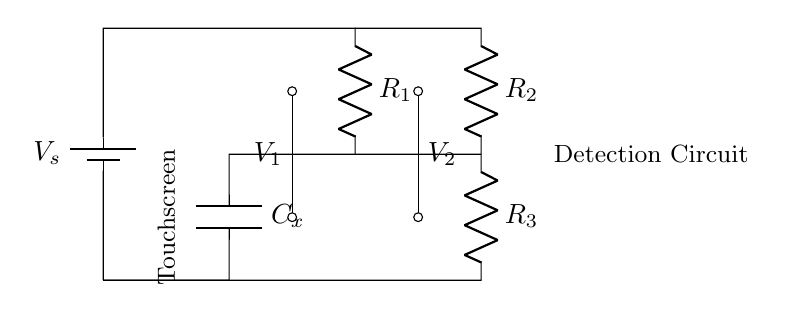What are the components used in the circuit? The circuit consists of a battery, resistors (R1, R2, R3), and a capacitor (Cx). Each component is crucial for the functioning of the capacitive bridge.
Answer: battery, resistors, capacitor What is the function of the capacitor in this circuit? The capacitor, labeled Cx, is used to detect changes in capacitance which corresponds to touch input on the touchscreen. It acts as the sensing element in the bridge circuit.
Answer: detect touch What is the voltage source labeled in the circuit? The voltage source is labeled as V_s, which is the supply voltage for the circuit. This component provides the necessary potential difference needed for the operation of the resistors and capacitor.
Answer: V_s Which resistors are in parallel with the capacitor? Resistors R1 and R3 are connected in parallel with the capacitor. This configuration forms part of the capacitive bridge, allowing the circuit to balance when no touch is detected.
Answer: R1, R3 What do V1 and V2 represent in the circuit? V1 and V2 represent the voltages at two distinct points in the bridge circuit that will vary based on the capacitance detected by the touchscreen input. These voltages are crucial for determining whether a touch has occurred.
Answer: voltages at touchpoints How does the circuit detect a touch? The circuit detects a touch by measuring the change in voltage across V1 and V2 caused by the variation in capacitance when a user's finger approaches the touchscreen. This difference indicates a touch input.
Answer: measuring voltage difference What type of circuit is this diagram illustrating? The diagram illustrates a capacitive bridge circuit, which is specifically used for touch input detection in handheld devices. It relies on capacitance changes to determine touch events.
Answer: capacitive bridge 